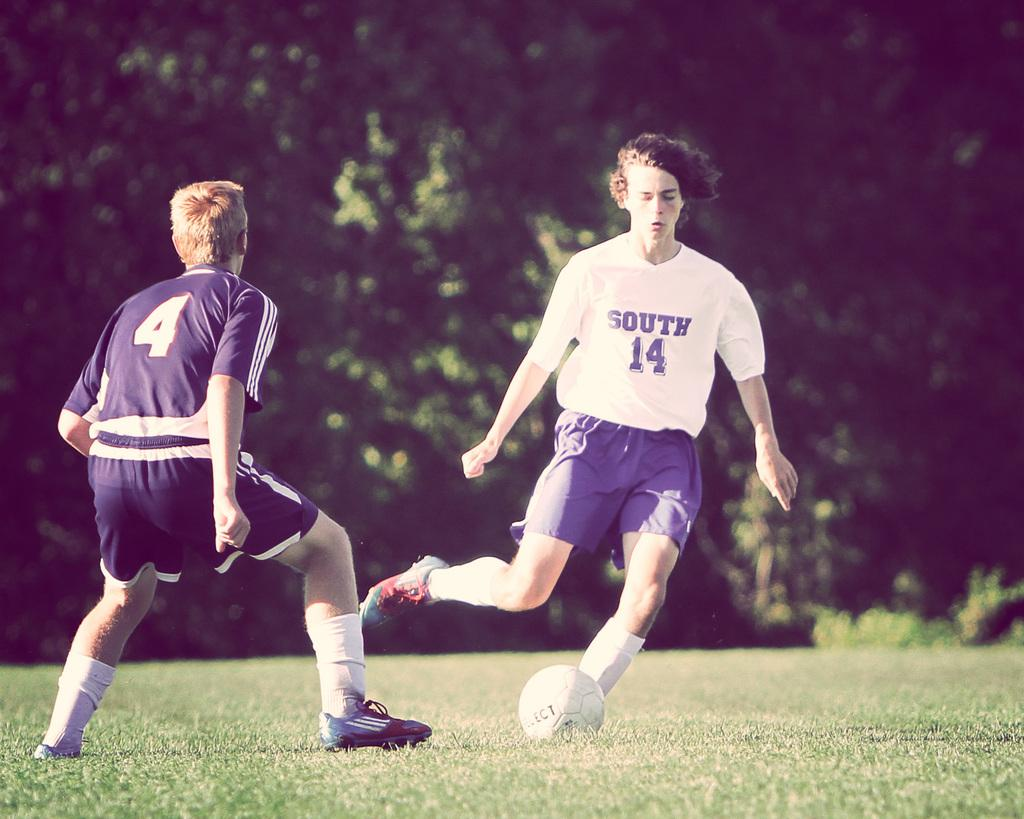<image>
Describe the image concisely. One male soccer player wears a white shirt that says "South 14" on it while another player wears a black shirt with the number 4 on it. 